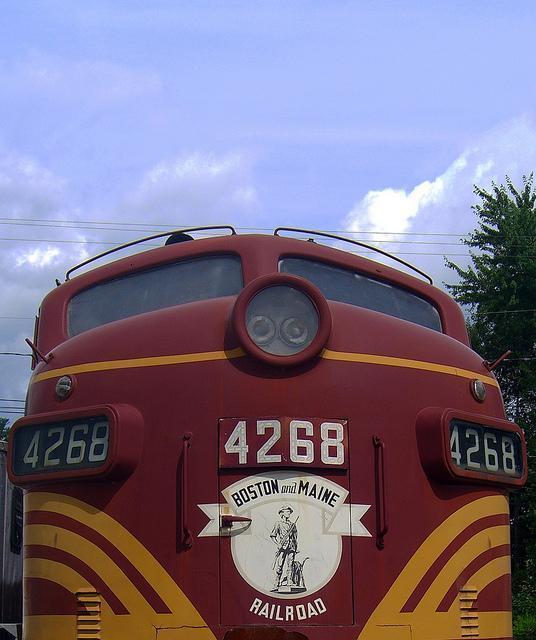How many people are wearing a red shirt?
Give a very brief answer. 0. 